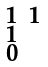<formula> <loc_0><loc_0><loc_500><loc_500>\begin{smallmatrix} 1 & 1 \\ 1 \\ 0 \end{smallmatrix}</formula> 